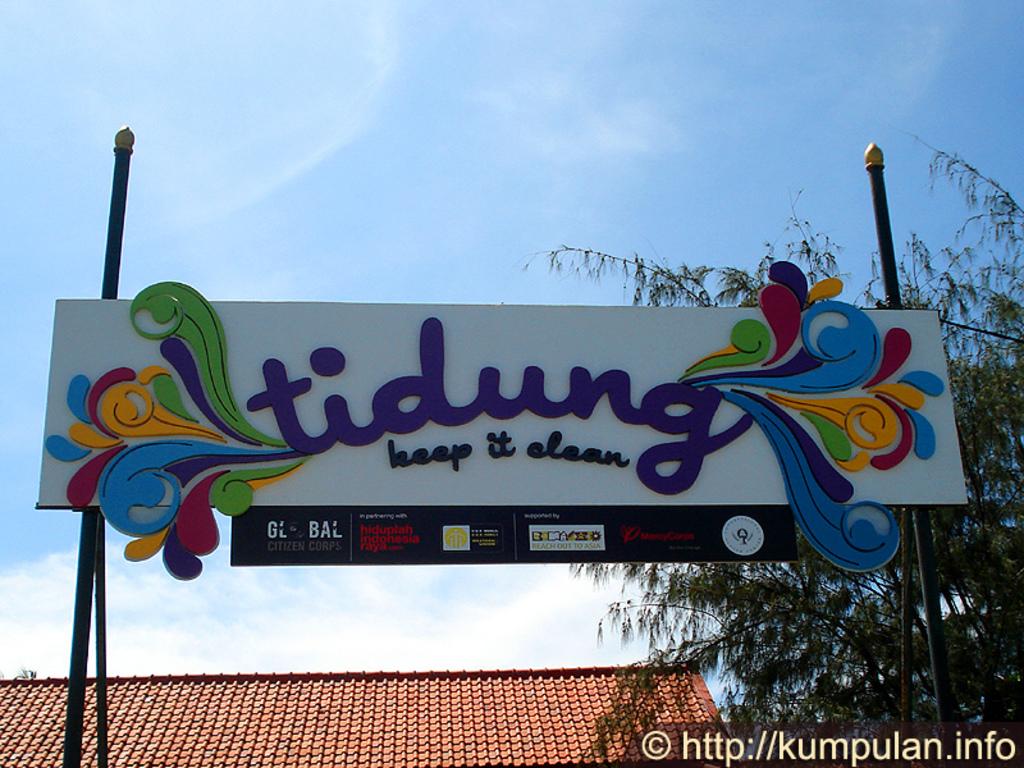What is the corp name on the bottom left?
Provide a short and direct response. Global citizen corps. 